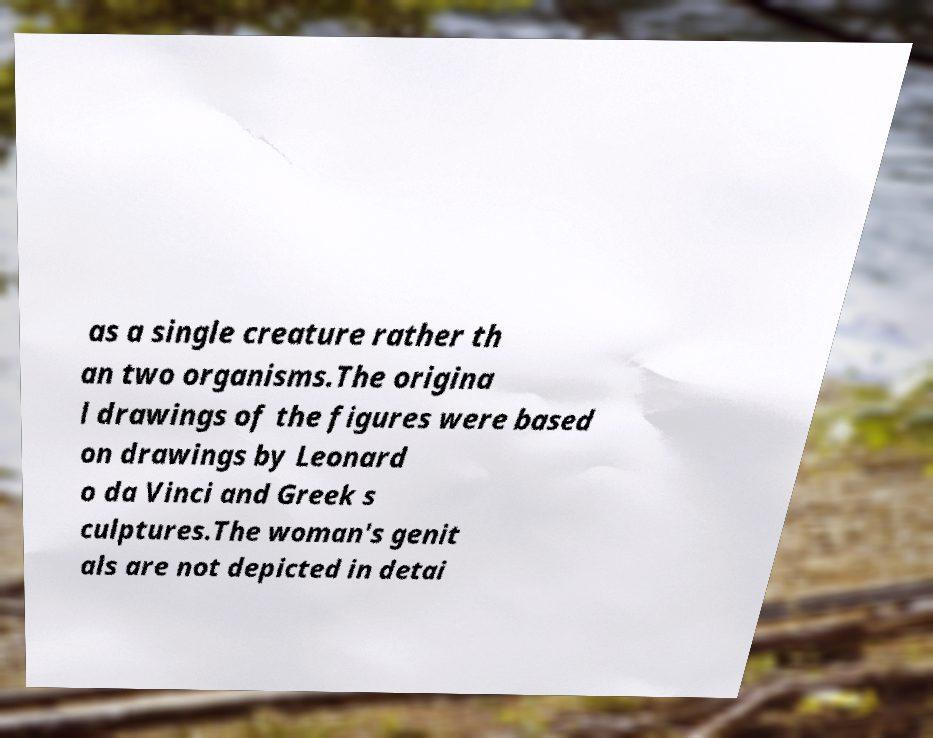Please read and relay the text visible in this image. What does it say? as a single creature rather th an two organisms.The origina l drawings of the figures were based on drawings by Leonard o da Vinci and Greek s culptures.The woman's genit als are not depicted in detai 